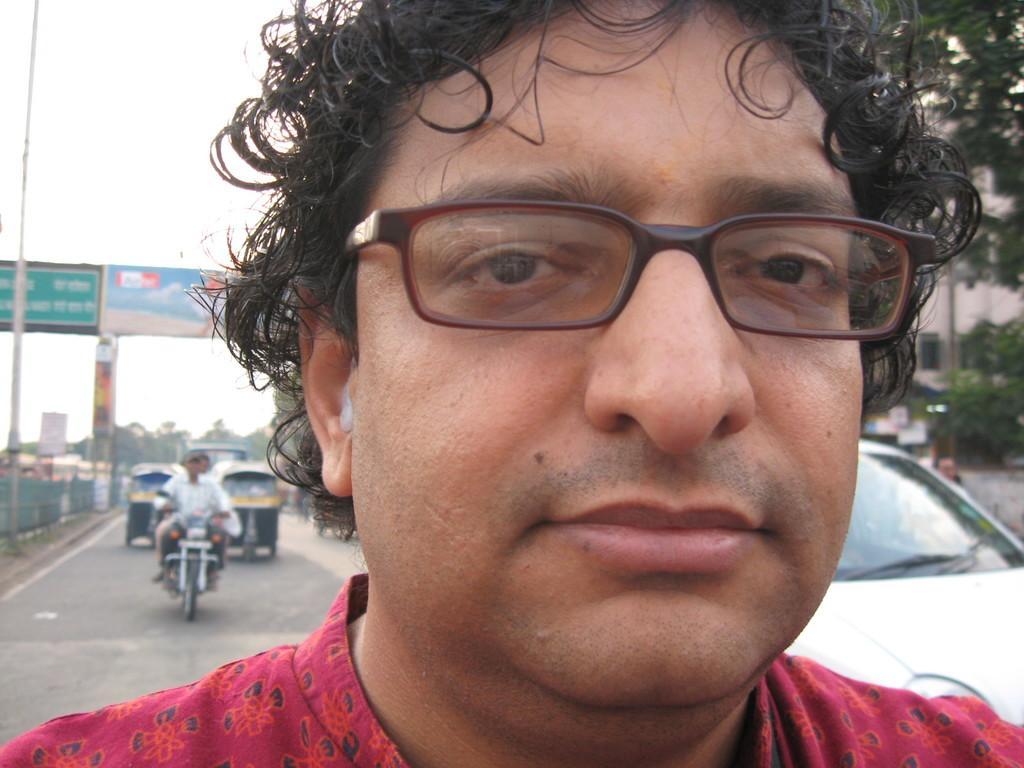Can you describe this image briefly? In this image, we can see a man, he is wearing specs. There are some vehicles on the road, there is a fencing on the left side. We can see some trees and a building. We can see the sky. 